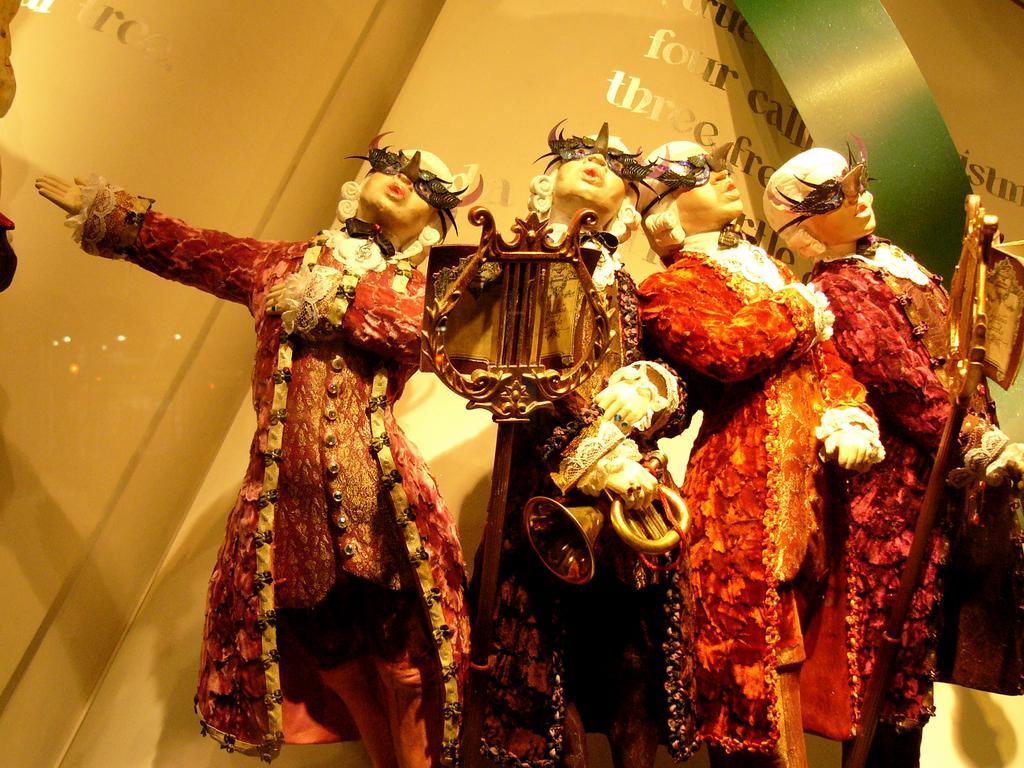How would you summarize this image in a sentence or two? In this image we can see depictions of persons. In the background of the image there is wall with some text. 